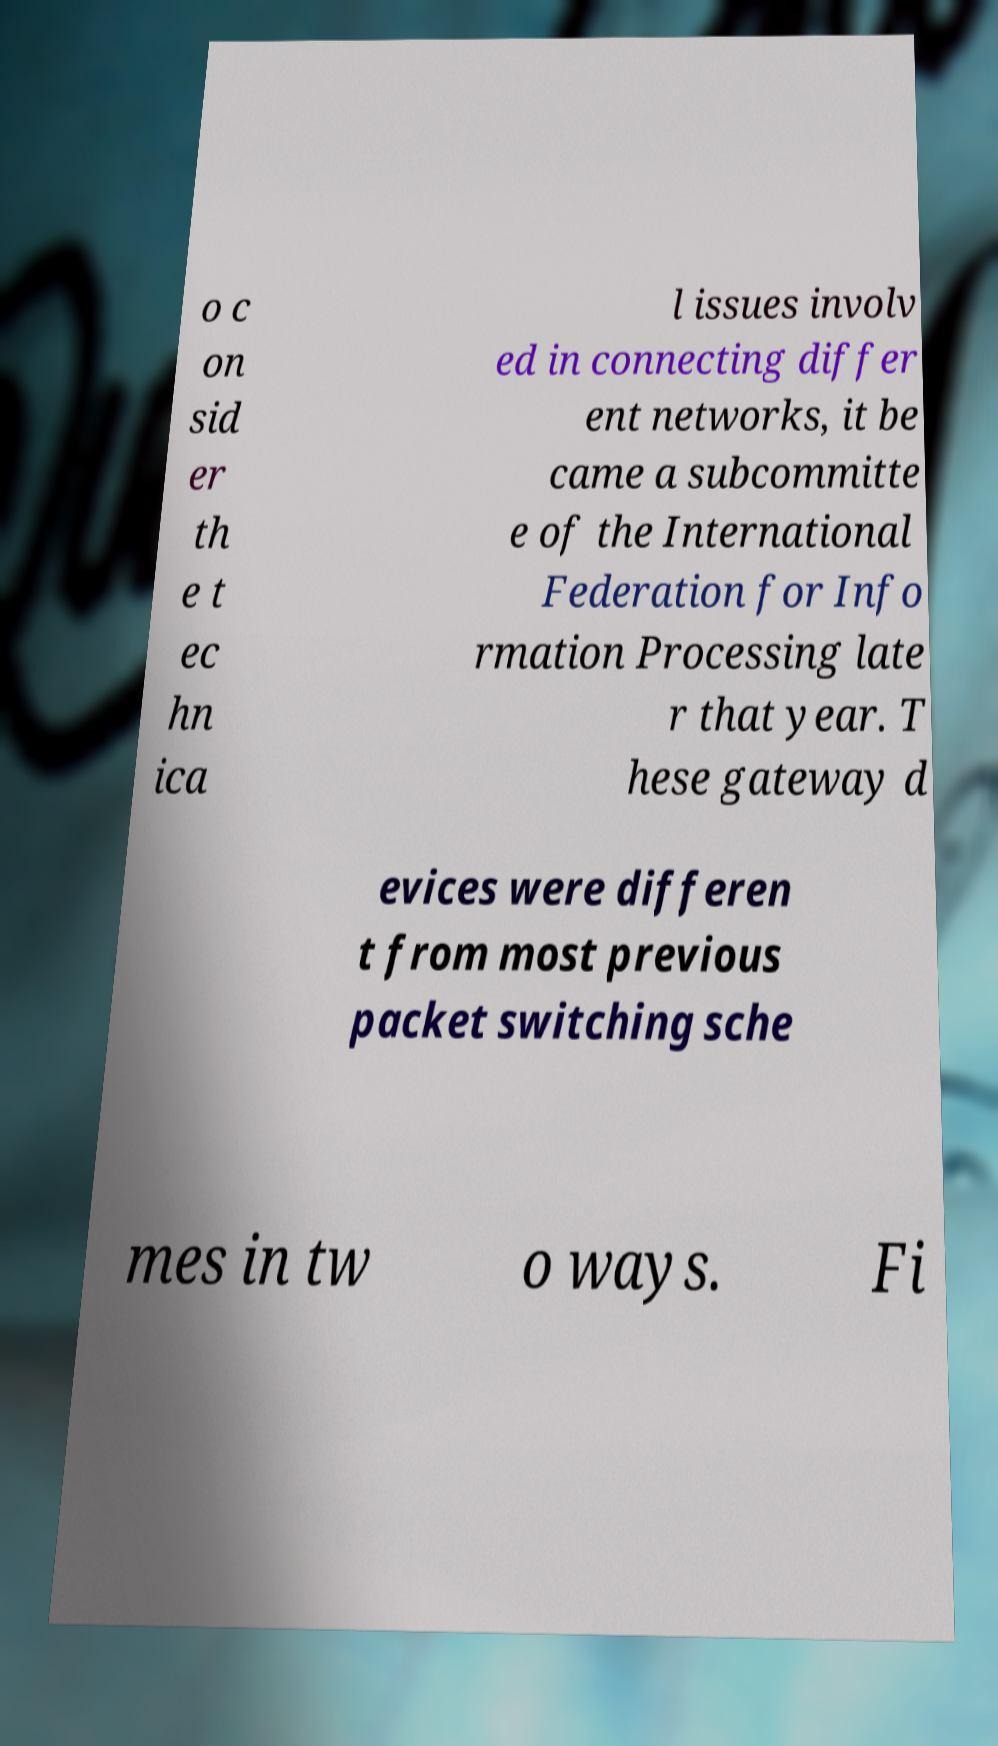For documentation purposes, I need the text within this image transcribed. Could you provide that? o c on sid er th e t ec hn ica l issues involv ed in connecting differ ent networks, it be came a subcommitte e of the International Federation for Info rmation Processing late r that year. T hese gateway d evices were differen t from most previous packet switching sche mes in tw o ways. Fi 